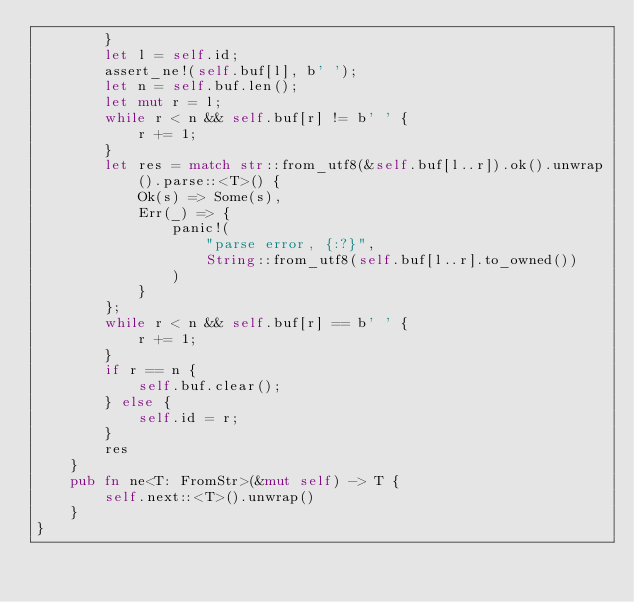<code> <loc_0><loc_0><loc_500><loc_500><_Rust_>        }
        let l = self.id;
        assert_ne!(self.buf[l], b' ');
        let n = self.buf.len();
        let mut r = l;
        while r < n && self.buf[r] != b' ' {
            r += 1;
        }
        let res = match str::from_utf8(&self.buf[l..r]).ok().unwrap().parse::<T>() {
            Ok(s) => Some(s),
            Err(_) => {
                panic!(
                    "parse error, {:?}",
                    String::from_utf8(self.buf[l..r].to_owned())
                )
            }
        };
        while r < n && self.buf[r] == b' ' {
            r += 1;
        }
        if r == n {
            self.buf.clear();
        } else {
            self.id = r;
        }
        res
    }
    pub fn ne<T: FromStr>(&mut self) -> T {
        self.next::<T>().unwrap()
    }
}
</code> 